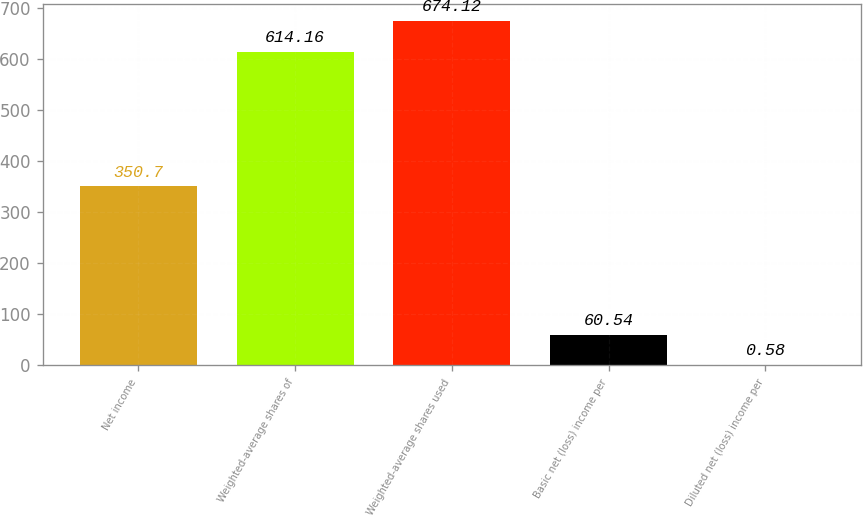Convert chart. <chart><loc_0><loc_0><loc_500><loc_500><bar_chart><fcel>Net income<fcel>Weighted-average shares of<fcel>Weighted-average shares used<fcel>Basic net (loss) income per<fcel>Diluted net (loss) income per<nl><fcel>350.7<fcel>614.16<fcel>674.12<fcel>60.54<fcel>0.58<nl></chart> 